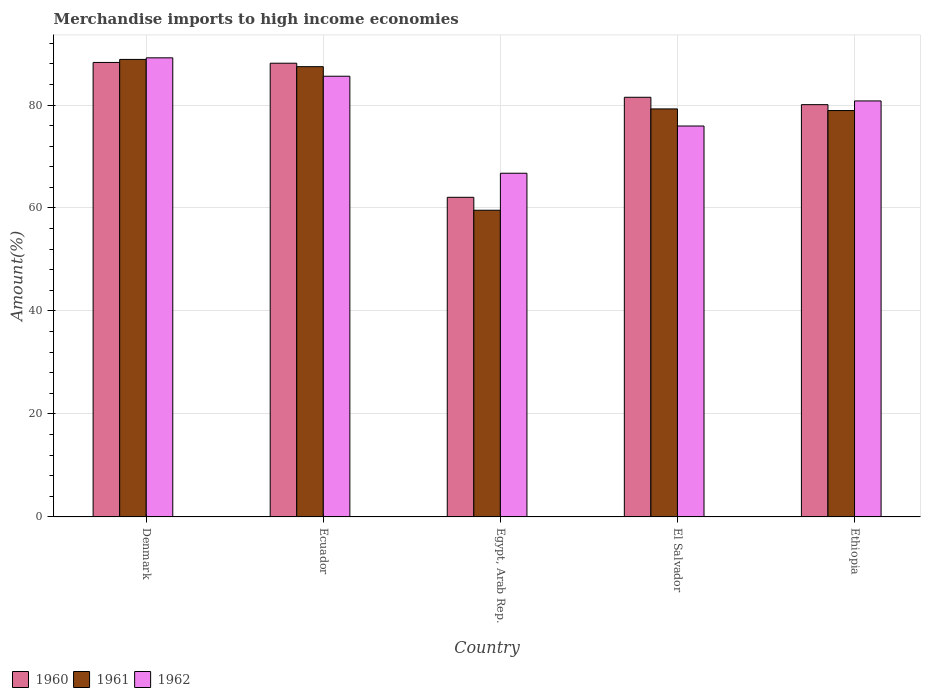How many different coloured bars are there?
Your answer should be compact. 3. How many groups of bars are there?
Offer a terse response. 5. Are the number of bars on each tick of the X-axis equal?
Provide a short and direct response. Yes. What is the label of the 2nd group of bars from the left?
Your response must be concise. Ecuador. What is the percentage of amount earned from merchandise imports in 1960 in Ecuador?
Offer a terse response. 88.12. Across all countries, what is the maximum percentage of amount earned from merchandise imports in 1960?
Your answer should be very brief. 88.27. Across all countries, what is the minimum percentage of amount earned from merchandise imports in 1962?
Offer a terse response. 66.75. In which country was the percentage of amount earned from merchandise imports in 1960 maximum?
Provide a short and direct response. Denmark. In which country was the percentage of amount earned from merchandise imports in 1962 minimum?
Provide a succinct answer. Egypt, Arab Rep. What is the total percentage of amount earned from merchandise imports in 1962 in the graph?
Offer a very short reply. 398.23. What is the difference between the percentage of amount earned from merchandise imports in 1962 in Egypt, Arab Rep. and that in El Salvador?
Offer a terse response. -9.17. What is the difference between the percentage of amount earned from merchandise imports in 1961 in Ecuador and the percentage of amount earned from merchandise imports in 1962 in El Salvador?
Make the answer very short. 11.53. What is the average percentage of amount earned from merchandise imports in 1962 per country?
Your response must be concise. 79.65. What is the difference between the percentage of amount earned from merchandise imports of/in 1962 and percentage of amount earned from merchandise imports of/in 1960 in Ecuador?
Provide a succinct answer. -2.53. What is the ratio of the percentage of amount earned from merchandise imports in 1962 in Denmark to that in Ecuador?
Ensure brevity in your answer.  1.04. What is the difference between the highest and the second highest percentage of amount earned from merchandise imports in 1961?
Give a very brief answer. 9.62. What is the difference between the highest and the lowest percentage of amount earned from merchandise imports in 1961?
Ensure brevity in your answer.  29.29. In how many countries, is the percentage of amount earned from merchandise imports in 1960 greater than the average percentage of amount earned from merchandise imports in 1960 taken over all countries?
Your answer should be very brief. 4. What does the 3rd bar from the left in Egypt, Arab Rep. represents?
Provide a succinct answer. 1962. What does the 2nd bar from the right in Denmark represents?
Your answer should be very brief. 1961. Is it the case that in every country, the sum of the percentage of amount earned from merchandise imports in 1960 and percentage of amount earned from merchandise imports in 1962 is greater than the percentage of amount earned from merchandise imports in 1961?
Your response must be concise. Yes. What is the difference between two consecutive major ticks on the Y-axis?
Offer a very short reply. 20. Does the graph contain any zero values?
Offer a terse response. No. Where does the legend appear in the graph?
Your response must be concise. Bottom left. How many legend labels are there?
Give a very brief answer. 3. How are the legend labels stacked?
Your answer should be compact. Horizontal. What is the title of the graph?
Your answer should be very brief. Merchandise imports to high income economies. What is the label or title of the Y-axis?
Offer a very short reply. Amount(%). What is the Amount(%) in 1960 in Denmark?
Offer a terse response. 88.27. What is the Amount(%) in 1961 in Denmark?
Keep it short and to the point. 88.86. What is the Amount(%) of 1962 in Denmark?
Make the answer very short. 89.17. What is the Amount(%) of 1960 in Ecuador?
Provide a succinct answer. 88.12. What is the Amount(%) of 1961 in Ecuador?
Your response must be concise. 87.45. What is the Amount(%) in 1962 in Ecuador?
Provide a succinct answer. 85.59. What is the Amount(%) of 1960 in Egypt, Arab Rep.?
Your answer should be compact. 62.08. What is the Amount(%) in 1961 in Egypt, Arab Rep.?
Offer a terse response. 59.56. What is the Amount(%) of 1962 in Egypt, Arab Rep.?
Make the answer very short. 66.75. What is the Amount(%) in 1960 in El Salvador?
Your answer should be compact. 81.51. What is the Amount(%) in 1961 in El Salvador?
Provide a succinct answer. 79.24. What is the Amount(%) of 1962 in El Salvador?
Provide a succinct answer. 75.92. What is the Amount(%) of 1960 in Ethiopia?
Your response must be concise. 80.07. What is the Amount(%) of 1961 in Ethiopia?
Provide a short and direct response. 78.92. What is the Amount(%) in 1962 in Ethiopia?
Offer a very short reply. 80.8. Across all countries, what is the maximum Amount(%) of 1960?
Give a very brief answer. 88.27. Across all countries, what is the maximum Amount(%) in 1961?
Your response must be concise. 88.86. Across all countries, what is the maximum Amount(%) of 1962?
Ensure brevity in your answer.  89.17. Across all countries, what is the minimum Amount(%) in 1960?
Give a very brief answer. 62.08. Across all countries, what is the minimum Amount(%) of 1961?
Make the answer very short. 59.56. Across all countries, what is the minimum Amount(%) in 1962?
Make the answer very short. 66.75. What is the total Amount(%) of 1960 in the graph?
Make the answer very short. 400.04. What is the total Amount(%) in 1961 in the graph?
Keep it short and to the point. 394.04. What is the total Amount(%) of 1962 in the graph?
Ensure brevity in your answer.  398.23. What is the difference between the Amount(%) in 1960 in Denmark and that in Ecuador?
Provide a succinct answer. 0.15. What is the difference between the Amount(%) of 1961 in Denmark and that in Ecuador?
Give a very brief answer. 1.41. What is the difference between the Amount(%) of 1962 in Denmark and that in Ecuador?
Provide a succinct answer. 3.57. What is the difference between the Amount(%) of 1960 in Denmark and that in Egypt, Arab Rep.?
Your answer should be very brief. 26.19. What is the difference between the Amount(%) in 1961 in Denmark and that in Egypt, Arab Rep.?
Ensure brevity in your answer.  29.29. What is the difference between the Amount(%) of 1962 in Denmark and that in Egypt, Arab Rep.?
Keep it short and to the point. 22.42. What is the difference between the Amount(%) of 1960 in Denmark and that in El Salvador?
Provide a succinct answer. 6.76. What is the difference between the Amount(%) in 1961 in Denmark and that in El Salvador?
Your answer should be compact. 9.62. What is the difference between the Amount(%) of 1962 in Denmark and that in El Salvador?
Keep it short and to the point. 13.24. What is the difference between the Amount(%) of 1960 in Denmark and that in Ethiopia?
Offer a terse response. 8.2. What is the difference between the Amount(%) of 1961 in Denmark and that in Ethiopia?
Your answer should be very brief. 9.93. What is the difference between the Amount(%) in 1962 in Denmark and that in Ethiopia?
Give a very brief answer. 8.37. What is the difference between the Amount(%) of 1960 in Ecuador and that in Egypt, Arab Rep.?
Make the answer very short. 26.04. What is the difference between the Amount(%) of 1961 in Ecuador and that in Egypt, Arab Rep.?
Provide a short and direct response. 27.89. What is the difference between the Amount(%) in 1962 in Ecuador and that in Egypt, Arab Rep.?
Ensure brevity in your answer.  18.84. What is the difference between the Amount(%) in 1960 in Ecuador and that in El Salvador?
Your answer should be very brief. 6.61. What is the difference between the Amount(%) in 1961 in Ecuador and that in El Salvador?
Keep it short and to the point. 8.21. What is the difference between the Amount(%) of 1962 in Ecuador and that in El Salvador?
Your response must be concise. 9.67. What is the difference between the Amount(%) of 1960 in Ecuador and that in Ethiopia?
Make the answer very short. 8.05. What is the difference between the Amount(%) in 1961 in Ecuador and that in Ethiopia?
Provide a succinct answer. 8.53. What is the difference between the Amount(%) in 1962 in Ecuador and that in Ethiopia?
Ensure brevity in your answer.  4.8. What is the difference between the Amount(%) of 1960 in Egypt, Arab Rep. and that in El Salvador?
Your answer should be compact. -19.43. What is the difference between the Amount(%) of 1961 in Egypt, Arab Rep. and that in El Salvador?
Offer a terse response. -19.68. What is the difference between the Amount(%) in 1962 in Egypt, Arab Rep. and that in El Salvador?
Provide a succinct answer. -9.17. What is the difference between the Amount(%) of 1960 in Egypt, Arab Rep. and that in Ethiopia?
Provide a succinct answer. -17.99. What is the difference between the Amount(%) in 1961 in Egypt, Arab Rep. and that in Ethiopia?
Ensure brevity in your answer.  -19.36. What is the difference between the Amount(%) in 1962 in Egypt, Arab Rep. and that in Ethiopia?
Provide a succinct answer. -14.05. What is the difference between the Amount(%) of 1960 in El Salvador and that in Ethiopia?
Keep it short and to the point. 1.43. What is the difference between the Amount(%) in 1961 in El Salvador and that in Ethiopia?
Your answer should be compact. 0.32. What is the difference between the Amount(%) of 1962 in El Salvador and that in Ethiopia?
Provide a short and direct response. -4.87. What is the difference between the Amount(%) of 1960 in Denmark and the Amount(%) of 1961 in Ecuador?
Offer a very short reply. 0.82. What is the difference between the Amount(%) of 1960 in Denmark and the Amount(%) of 1962 in Ecuador?
Provide a short and direct response. 2.67. What is the difference between the Amount(%) in 1961 in Denmark and the Amount(%) in 1962 in Ecuador?
Provide a succinct answer. 3.27. What is the difference between the Amount(%) of 1960 in Denmark and the Amount(%) of 1961 in Egypt, Arab Rep.?
Provide a short and direct response. 28.7. What is the difference between the Amount(%) of 1960 in Denmark and the Amount(%) of 1962 in Egypt, Arab Rep.?
Ensure brevity in your answer.  21.52. What is the difference between the Amount(%) of 1961 in Denmark and the Amount(%) of 1962 in Egypt, Arab Rep.?
Your answer should be compact. 22.11. What is the difference between the Amount(%) in 1960 in Denmark and the Amount(%) in 1961 in El Salvador?
Provide a short and direct response. 9.02. What is the difference between the Amount(%) in 1960 in Denmark and the Amount(%) in 1962 in El Salvador?
Ensure brevity in your answer.  12.34. What is the difference between the Amount(%) of 1961 in Denmark and the Amount(%) of 1962 in El Salvador?
Your response must be concise. 12.94. What is the difference between the Amount(%) of 1960 in Denmark and the Amount(%) of 1961 in Ethiopia?
Offer a terse response. 9.34. What is the difference between the Amount(%) of 1960 in Denmark and the Amount(%) of 1962 in Ethiopia?
Offer a very short reply. 7.47. What is the difference between the Amount(%) in 1961 in Denmark and the Amount(%) in 1962 in Ethiopia?
Offer a terse response. 8.06. What is the difference between the Amount(%) of 1960 in Ecuador and the Amount(%) of 1961 in Egypt, Arab Rep.?
Your response must be concise. 28.56. What is the difference between the Amount(%) of 1960 in Ecuador and the Amount(%) of 1962 in Egypt, Arab Rep.?
Provide a short and direct response. 21.37. What is the difference between the Amount(%) of 1961 in Ecuador and the Amount(%) of 1962 in Egypt, Arab Rep.?
Your response must be concise. 20.7. What is the difference between the Amount(%) of 1960 in Ecuador and the Amount(%) of 1961 in El Salvador?
Your answer should be very brief. 8.88. What is the difference between the Amount(%) of 1960 in Ecuador and the Amount(%) of 1962 in El Salvador?
Ensure brevity in your answer.  12.2. What is the difference between the Amount(%) of 1961 in Ecuador and the Amount(%) of 1962 in El Salvador?
Offer a very short reply. 11.53. What is the difference between the Amount(%) in 1960 in Ecuador and the Amount(%) in 1961 in Ethiopia?
Your answer should be very brief. 9.19. What is the difference between the Amount(%) of 1960 in Ecuador and the Amount(%) of 1962 in Ethiopia?
Make the answer very short. 7.32. What is the difference between the Amount(%) of 1961 in Ecuador and the Amount(%) of 1962 in Ethiopia?
Your response must be concise. 6.65. What is the difference between the Amount(%) of 1960 in Egypt, Arab Rep. and the Amount(%) of 1961 in El Salvador?
Keep it short and to the point. -17.17. What is the difference between the Amount(%) in 1960 in Egypt, Arab Rep. and the Amount(%) in 1962 in El Salvador?
Offer a very short reply. -13.84. What is the difference between the Amount(%) of 1961 in Egypt, Arab Rep. and the Amount(%) of 1962 in El Salvador?
Keep it short and to the point. -16.36. What is the difference between the Amount(%) in 1960 in Egypt, Arab Rep. and the Amount(%) in 1961 in Ethiopia?
Offer a very short reply. -16.85. What is the difference between the Amount(%) in 1960 in Egypt, Arab Rep. and the Amount(%) in 1962 in Ethiopia?
Your answer should be very brief. -18.72. What is the difference between the Amount(%) of 1961 in Egypt, Arab Rep. and the Amount(%) of 1962 in Ethiopia?
Ensure brevity in your answer.  -21.23. What is the difference between the Amount(%) in 1960 in El Salvador and the Amount(%) in 1961 in Ethiopia?
Provide a succinct answer. 2.58. What is the difference between the Amount(%) in 1960 in El Salvador and the Amount(%) in 1962 in Ethiopia?
Your answer should be compact. 0.71. What is the difference between the Amount(%) of 1961 in El Salvador and the Amount(%) of 1962 in Ethiopia?
Give a very brief answer. -1.55. What is the average Amount(%) of 1960 per country?
Provide a short and direct response. 80.01. What is the average Amount(%) of 1961 per country?
Give a very brief answer. 78.81. What is the average Amount(%) in 1962 per country?
Your response must be concise. 79.65. What is the difference between the Amount(%) of 1960 and Amount(%) of 1961 in Denmark?
Your response must be concise. -0.59. What is the difference between the Amount(%) in 1960 and Amount(%) in 1962 in Denmark?
Offer a terse response. -0.9. What is the difference between the Amount(%) of 1961 and Amount(%) of 1962 in Denmark?
Ensure brevity in your answer.  -0.31. What is the difference between the Amount(%) of 1960 and Amount(%) of 1961 in Ecuador?
Keep it short and to the point. 0.67. What is the difference between the Amount(%) in 1960 and Amount(%) in 1962 in Ecuador?
Ensure brevity in your answer.  2.53. What is the difference between the Amount(%) of 1961 and Amount(%) of 1962 in Ecuador?
Ensure brevity in your answer.  1.86. What is the difference between the Amount(%) of 1960 and Amount(%) of 1961 in Egypt, Arab Rep.?
Offer a very short reply. 2.51. What is the difference between the Amount(%) of 1960 and Amount(%) of 1962 in Egypt, Arab Rep.?
Offer a terse response. -4.67. What is the difference between the Amount(%) of 1961 and Amount(%) of 1962 in Egypt, Arab Rep.?
Give a very brief answer. -7.19. What is the difference between the Amount(%) of 1960 and Amount(%) of 1961 in El Salvador?
Make the answer very short. 2.26. What is the difference between the Amount(%) of 1960 and Amount(%) of 1962 in El Salvador?
Ensure brevity in your answer.  5.58. What is the difference between the Amount(%) of 1961 and Amount(%) of 1962 in El Salvador?
Make the answer very short. 3.32. What is the difference between the Amount(%) of 1960 and Amount(%) of 1961 in Ethiopia?
Offer a terse response. 1.15. What is the difference between the Amount(%) of 1960 and Amount(%) of 1962 in Ethiopia?
Offer a very short reply. -0.72. What is the difference between the Amount(%) of 1961 and Amount(%) of 1962 in Ethiopia?
Ensure brevity in your answer.  -1.87. What is the ratio of the Amount(%) in 1961 in Denmark to that in Ecuador?
Provide a succinct answer. 1.02. What is the ratio of the Amount(%) in 1962 in Denmark to that in Ecuador?
Give a very brief answer. 1.04. What is the ratio of the Amount(%) of 1960 in Denmark to that in Egypt, Arab Rep.?
Give a very brief answer. 1.42. What is the ratio of the Amount(%) in 1961 in Denmark to that in Egypt, Arab Rep.?
Ensure brevity in your answer.  1.49. What is the ratio of the Amount(%) in 1962 in Denmark to that in Egypt, Arab Rep.?
Provide a short and direct response. 1.34. What is the ratio of the Amount(%) of 1960 in Denmark to that in El Salvador?
Give a very brief answer. 1.08. What is the ratio of the Amount(%) in 1961 in Denmark to that in El Salvador?
Offer a very short reply. 1.12. What is the ratio of the Amount(%) in 1962 in Denmark to that in El Salvador?
Give a very brief answer. 1.17. What is the ratio of the Amount(%) in 1960 in Denmark to that in Ethiopia?
Your response must be concise. 1.1. What is the ratio of the Amount(%) of 1961 in Denmark to that in Ethiopia?
Ensure brevity in your answer.  1.13. What is the ratio of the Amount(%) in 1962 in Denmark to that in Ethiopia?
Provide a succinct answer. 1.1. What is the ratio of the Amount(%) in 1960 in Ecuador to that in Egypt, Arab Rep.?
Offer a very short reply. 1.42. What is the ratio of the Amount(%) in 1961 in Ecuador to that in Egypt, Arab Rep.?
Give a very brief answer. 1.47. What is the ratio of the Amount(%) of 1962 in Ecuador to that in Egypt, Arab Rep.?
Offer a terse response. 1.28. What is the ratio of the Amount(%) of 1960 in Ecuador to that in El Salvador?
Give a very brief answer. 1.08. What is the ratio of the Amount(%) of 1961 in Ecuador to that in El Salvador?
Your response must be concise. 1.1. What is the ratio of the Amount(%) of 1962 in Ecuador to that in El Salvador?
Offer a terse response. 1.13. What is the ratio of the Amount(%) of 1960 in Ecuador to that in Ethiopia?
Keep it short and to the point. 1.1. What is the ratio of the Amount(%) of 1961 in Ecuador to that in Ethiopia?
Your answer should be compact. 1.11. What is the ratio of the Amount(%) of 1962 in Ecuador to that in Ethiopia?
Your answer should be compact. 1.06. What is the ratio of the Amount(%) in 1960 in Egypt, Arab Rep. to that in El Salvador?
Provide a short and direct response. 0.76. What is the ratio of the Amount(%) in 1961 in Egypt, Arab Rep. to that in El Salvador?
Provide a short and direct response. 0.75. What is the ratio of the Amount(%) of 1962 in Egypt, Arab Rep. to that in El Salvador?
Make the answer very short. 0.88. What is the ratio of the Amount(%) of 1960 in Egypt, Arab Rep. to that in Ethiopia?
Your response must be concise. 0.78. What is the ratio of the Amount(%) of 1961 in Egypt, Arab Rep. to that in Ethiopia?
Ensure brevity in your answer.  0.75. What is the ratio of the Amount(%) of 1962 in Egypt, Arab Rep. to that in Ethiopia?
Offer a terse response. 0.83. What is the ratio of the Amount(%) of 1960 in El Salvador to that in Ethiopia?
Offer a very short reply. 1.02. What is the ratio of the Amount(%) in 1961 in El Salvador to that in Ethiopia?
Provide a short and direct response. 1. What is the ratio of the Amount(%) of 1962 in El Salvador to that in Ethiopia?
Offer a terse response. 0.94. What is the difference between the highest and the second highest Amount(%) in 1960?
Your answer should be compact. 0.15. What is the difference between the highest and the second highest Amount(%) of 1961?
Give a very brief answer. 1.41. What is the difference between the highest and the second highest Amount(%) in 1962?
Your answer should be very brief. 3.57. What is the difference between the highest and the lowest Amount(%) in 1960?
Offer a terse response. 26.19. What is the difference between the highest and the lowest Amount(%) in 1961?
Provide a short and direct response. 29.29. What is the difference between the highest and the lowest Amount(%) in 1962?
Your answer should be compact. 22.42. 